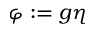Convert formula to latex. <formula><loc_0><loc_0><loc_500><loc_500>\varphi \colon = g \eta</formula> 